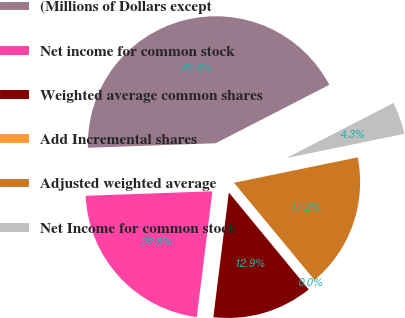Convert chart to OTSL. <chart><loc_0><loc_0><loc_500><loc_500><pie_chart><fcel>(Millions of Dollars except<fcel>Net income for common stock<fcel>Weighted average common shares<fcel>Add Incremental shares<fcel>Adjusted weighted average<fcel>Net Income for common stock<nl><fcel>43.0%<fcel>22.47%<fcel>12.93%<fcel>0.04%<fcel>17.22%<fcel>4.33%<nl></chart> 